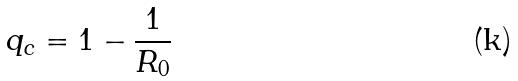<formula> <loc_0><loc_0><loc_500><loc_500>q _ { c } = 1 - \frac { 1 } { R _ { 0 } }</formula> 